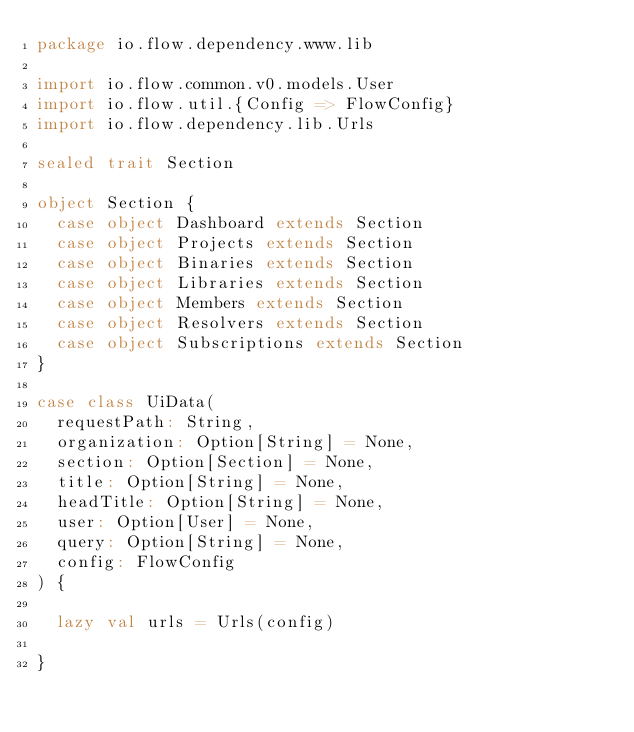Convert code to text. <code><loc_0><loc_0><loc_500><loc_500><_Scala_>package io.flow.dependency.www.lib

import io.flow.common.v0.models.User
import io.flow.util.{Config => FlowConfig}
import io.flow.dependency.lib.Urls

sealed trait Section

object Section {
  case object Dashboard extends Section
  case object Projects extends Section
  case object Binaries extends Section
  case object Libraries extends Section
  case object Members extends Section
  case object Resolvers extends Section
  case object Subscriptions extends Section
}

case class UiData(
  requestPath: String,
  organization: Option[String] = None,
  section: Option[Section] = None,
  title: Option[String] = None,
  headTitle: Option[String] = None,
  user: Option[User] = None,
  query: Option[String] = None,
  config: FlowConfig
) {

  lazy val urls = Urls(config)

}
</code> 